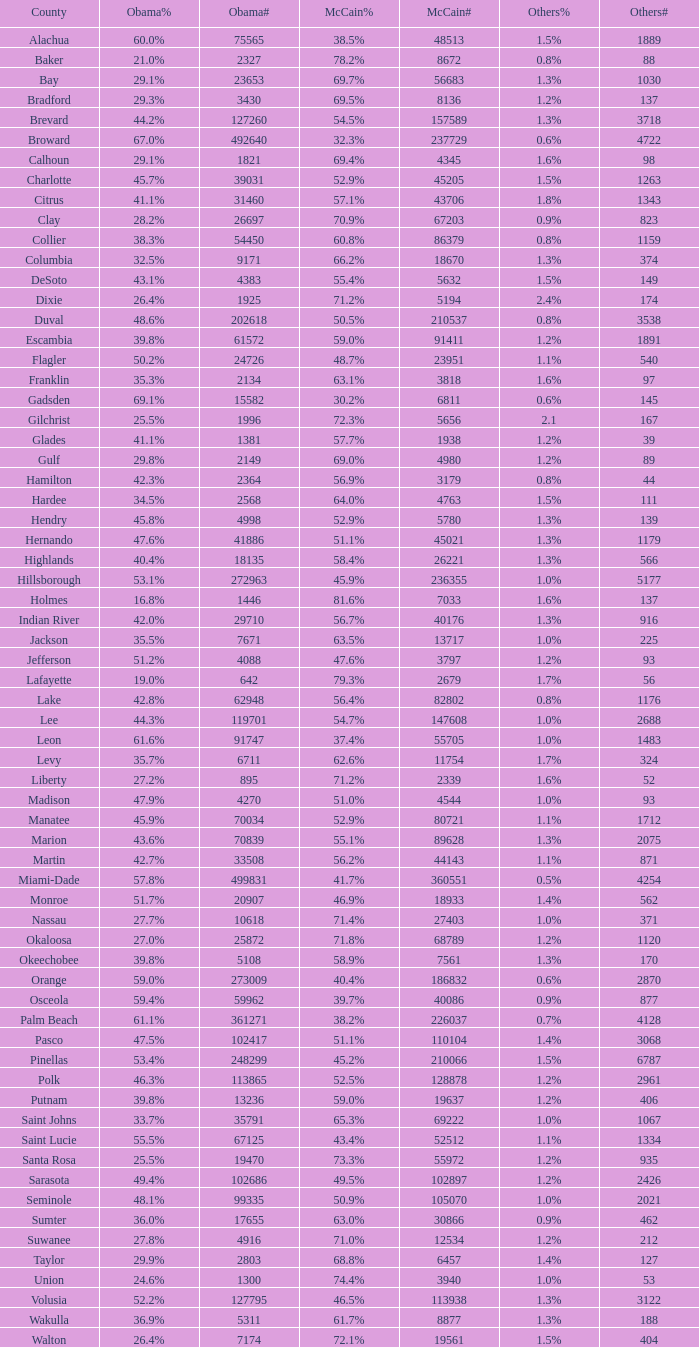How many numbers were recorded under Obama when he had 29.9% voters? 1.0. 